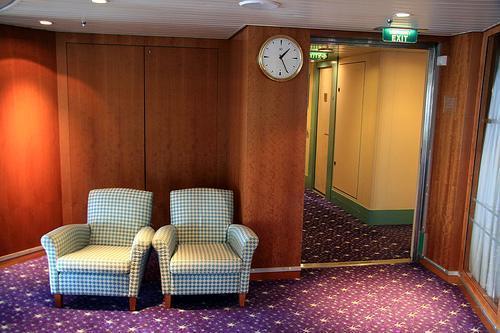How many chairs are there?
Give a very brief answer. 2. How many clocks are in the picture?
Give a very brief answer. 1. How many animals are in the photo?
Give a very brief answer. 0. 